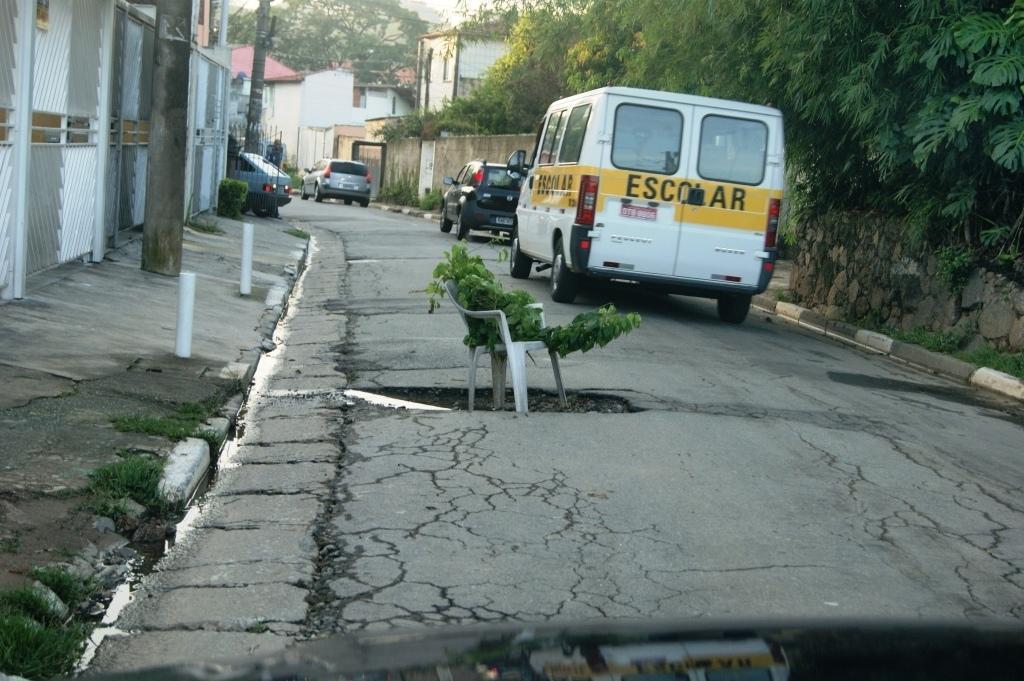Please provide a concise description of this image. In this image we can see few vehicles on the road, a chair with branch of tree and there are poles, rods, few buildings and trees. 